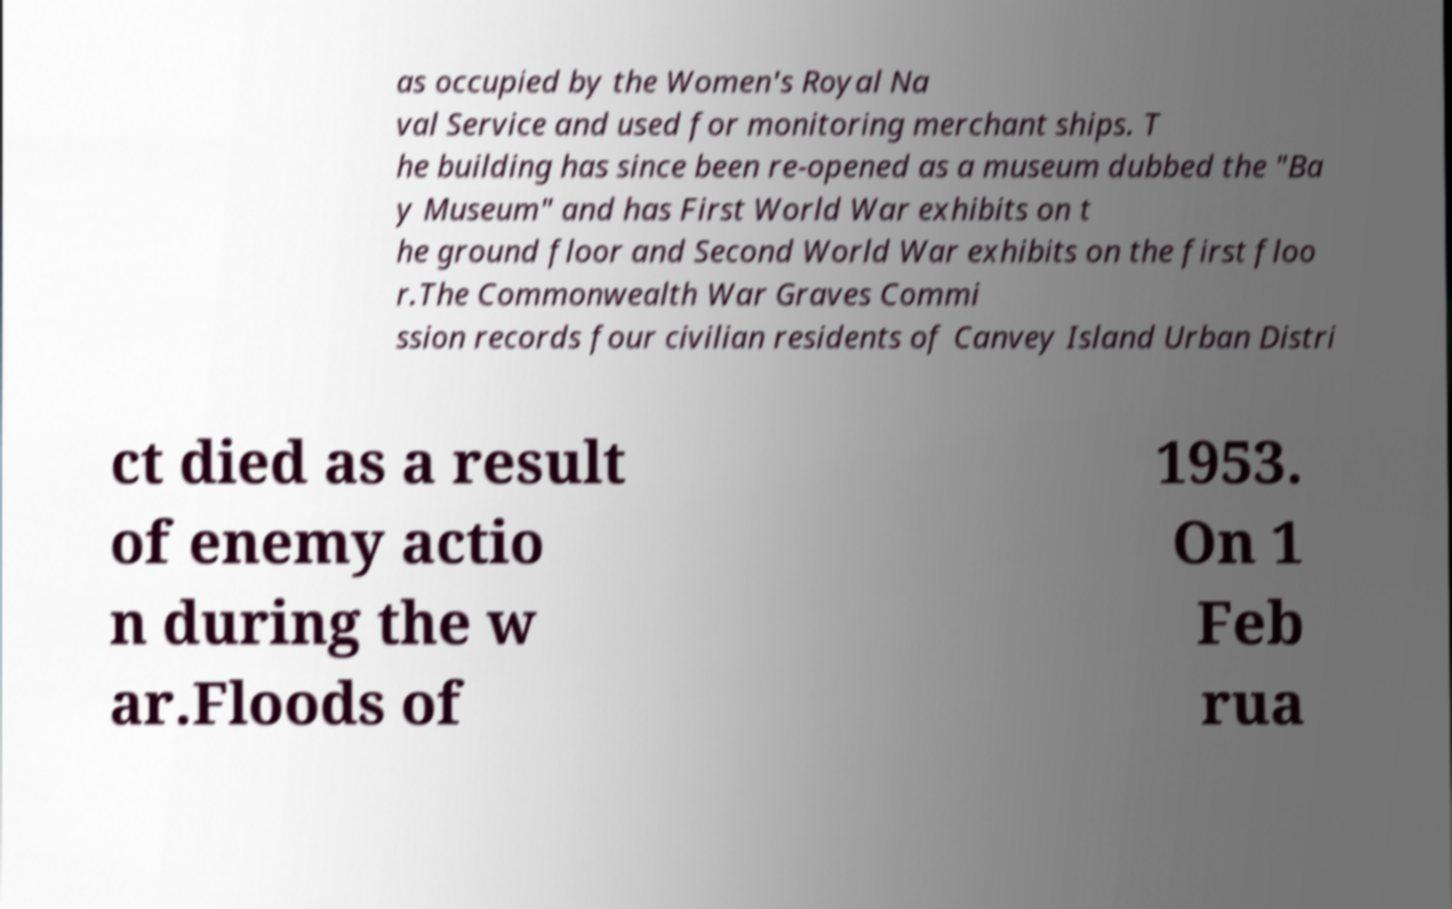Could you extract and type out the text from this image? as occupied by the Women's Royal Na val Service and used for monitoring merchant ships. T he building has since been re-opened as a museum dubbed the "Ba y Museum" and has First World War exhibits on t he ground floor and Second World War exhibits on the first floo r.The Commonwealth War Graves Commi ssion records four civilian residents of Canvey Island Urban Distri ct died as a result of enemy actio n during the w ar.Floods of 1953. On 1 Feb rua 